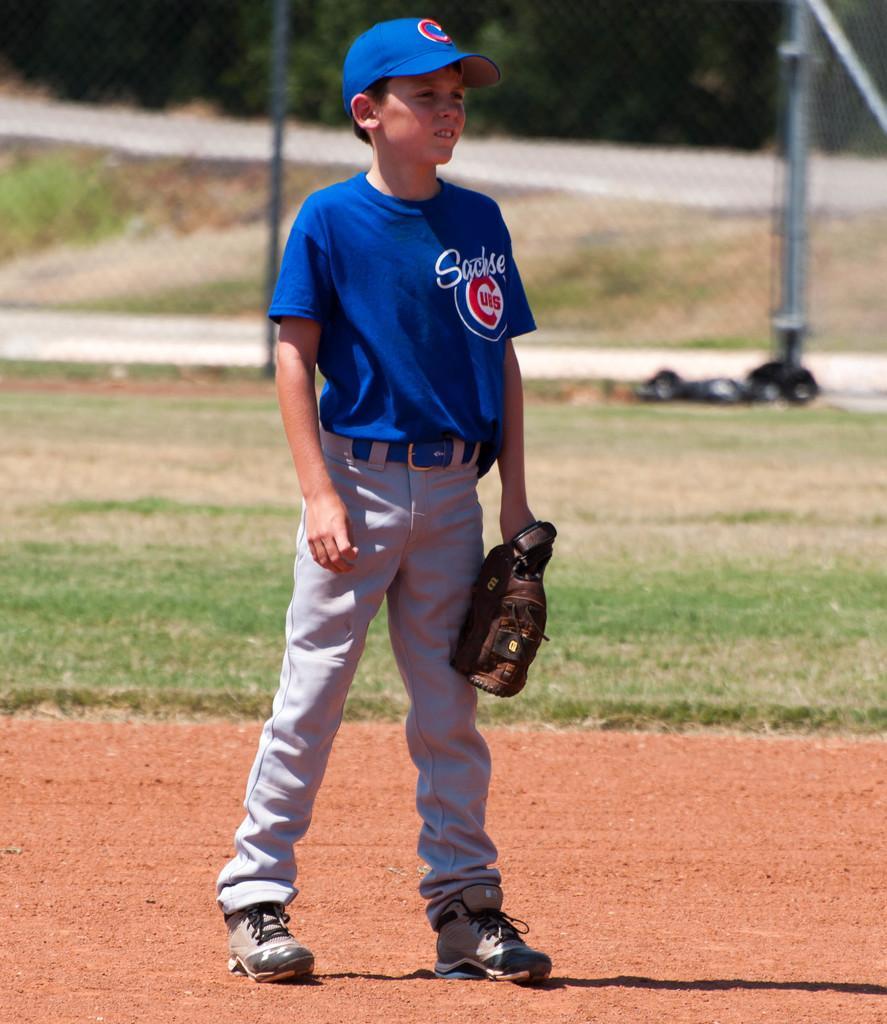Please provide a concise description of this image. In this image there is a boy holding an object visible on the ground, behind him there is a fence. 